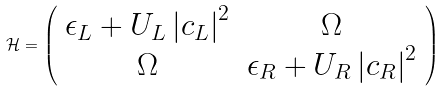Convert formula to latex. <formula><loc_0><loc_0><loc_500><loc_500>\mathcal { H } = \left ( \begin{array} { c c } \epsilon _ { L } + U _ { L } \left | c _ { L } \right | ^ { 2 } & \Omega \\ \Omega & \epsilon _ { R } + U _ { R } \left | c _ { R } \right | ^ { 2 } \end{array} \right )</formula> 